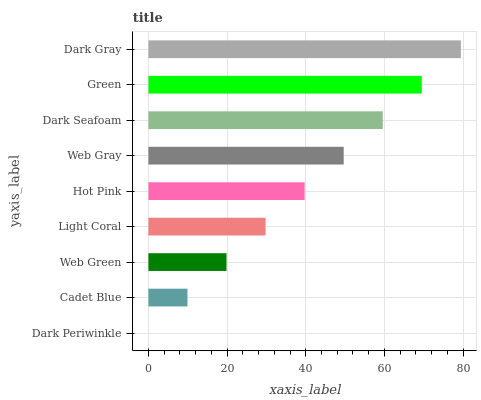Is Dark Periwinkle the minimum?
Answer yes or no. Yes. Is Dark Gray the maximum?
Answer yes or no. Yes. Is Cadet Blue the minimum?
Answer yes or no. No. Is Cadet Blue the maximum?
Answer yes or no. No. Is Cadet Blue greater than Dark Periwinkle?
Answer yes or no. Yes. Is Dark Periwinkle less than Cadet Blue?
Answer yes or no. Yes. Is Dark Periwinkle greater than Cadet Blue?
Answer yes or no. No. Is Cadet Blue less than Dark Periwinkle?
Answer yes or no. No. Is Hot Pink the high median?
Answer yes or no. Yes. Is Hot Pink the low median?
Answer yes or no. Yes. Is Dark Periwinkle the high median?
Answer yes or no. No. Is Green the low median?
Answer yes or no. No. 